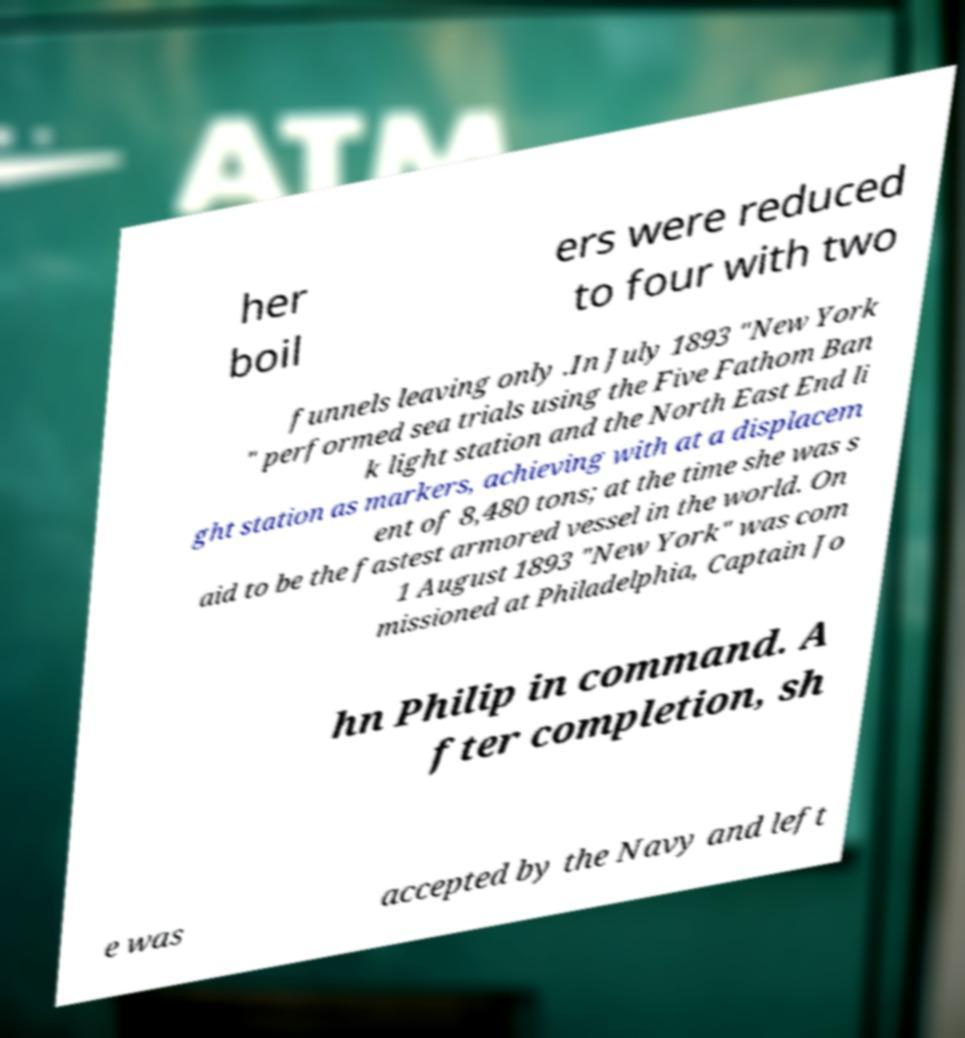There's text embedded in this image that I need extracted. Can you transcribe it verbatim? her boil ers were reduced to four with two funnels leaving only .In July 1893 "New York " performed sea trials using the Five Fathom Ban k light station and the North East End li ght station as markers, achieving with at a displacem ent of 8,480 tons; at the time she was s aid to be the fastest armored vessel in the world. On 1 August 1893 "New York" was com missioned at Philadelphia, Captain Jo hn Philip in command. A fter completion, sh e was accepted by the Navy and left 